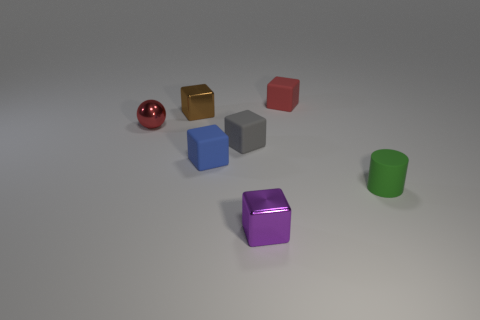Is there a small thing that has the same color as the tiny ball?
Keep it short and to the point. Yes. The object that is left of the small gray matte block and to the right of the tiny brown thing is what color?
Give a very brief answer. Blue. How big is the brown metallic cube in front of the cube right of the shiny thing that is in front of the red shiny object?
Make the answer very short. Small. What is the material of the purple cube?
Your response must be concise. Metal. Is the material of the small red cube the same as the small red thing that is on the left side of the gray matte thing?
Ensure brevity in your answer.  No. Are there any other things that have the same color as the cylinder?
Ensure brevity in your answer.  No. There is a tiny metal block that is in front of the small rubber thing that is to the left of the tiny gray block; are there any small red things behind it?
Your answer should be compact. Yes. What color is the small cylinder?
Keep it short and to the point. Green. There is a small purple metallic thing; are there any red objects right of it?
Keep it short and to the point. Yes. Is the shape of the tiny red matte thing the same as the purple object in front of the gray matte block?
Provide a short and direct response. Yes. 